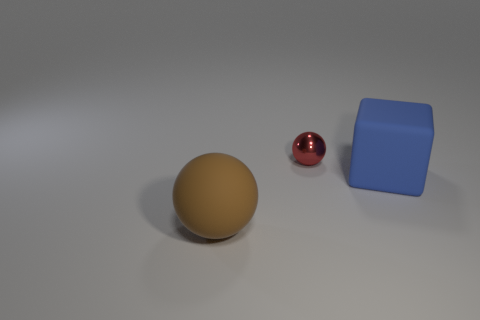Is there any other thing that is the same size as the red sphere?
Give a very brief answer. No. There is a matte sphere that is the same size as the blue matte thing; what is its color?
Make the answer very short. Brown. Are there any brown things of the same shape as the small red object?
Your response must be concise. Yes. There is a shiny object left of the large rubber object behind the sphere that is in front of the large blue block; what is its color?
Your response must be concise. Red. What number of metal objects are either large spheres or big blue things?
Offer a very short reply. 0. Is the number of large blue blocks that are to the right of the metal ball greater than the number of blocks that are in front of the brown sphere?
Provide a succinct answer. Yes. How many other things are there of the same size as the red object?
Provide a succinct answer. 0. What size is the ball in front of the ball behind the brown thing?
Make the answer very short. Large. How many tiny things are either brown matte balls or cubes?
Give a very brief answer. 0. How big is the matte object that is on the right side of the matte object that is in front of the large thing that is behind the big brown matte ball?
Give a very brief answer. Large. 